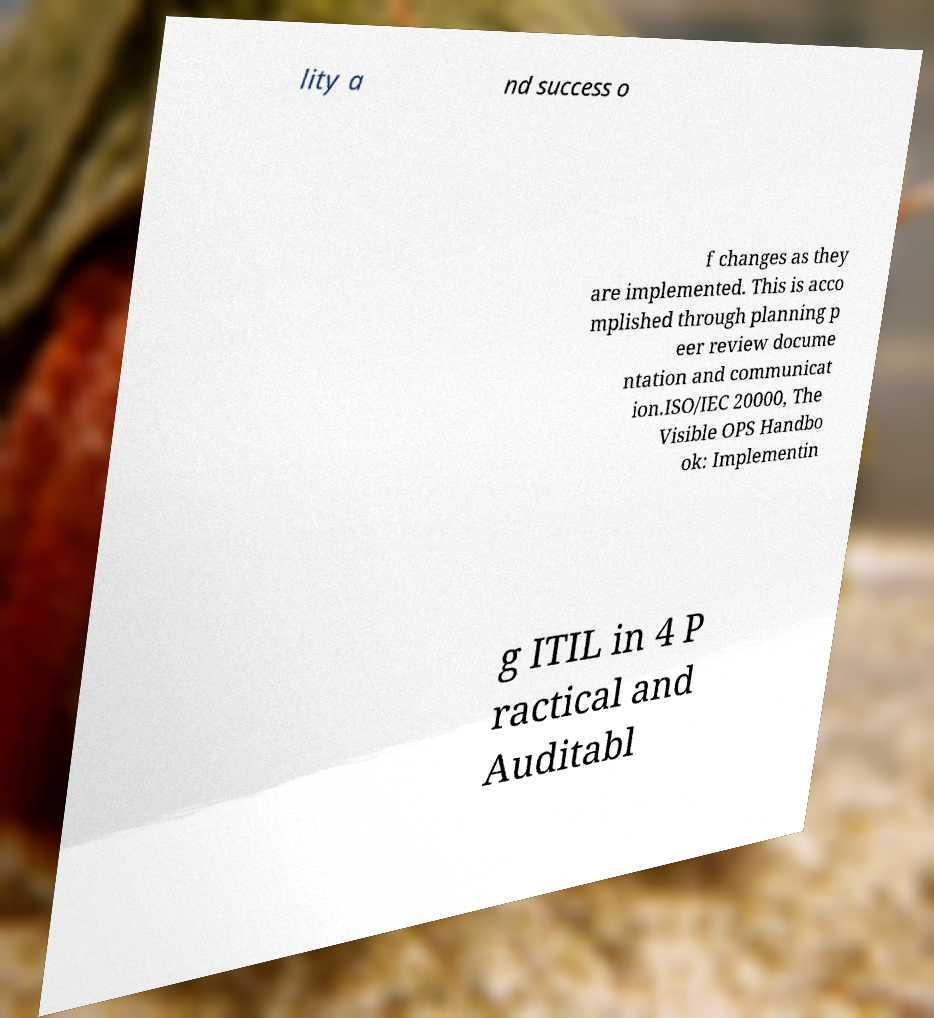Please read and relay the text visible in this image. What does it say? lity a nd success o f changes as they are implemented. This is acco mplished through planning p eer review docume ntation and communicat ion.ISO/IEC 20000, The Visible OPS Handbo ok: Implementin g ITIL in 4 P ractical and Auditabl 